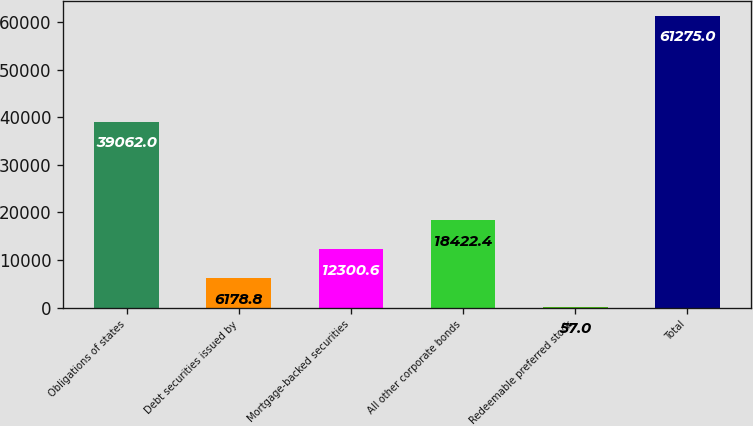<chart> <loc_0><loc_0><loc_500><loc_500><bar_chart><fcel>Obligations of states<fcel>Debt securities issued by<fcel>Mortgage-backed securities<fcel>All other corporate bonds<fcel>Redeemable preferred stock<fcel>Total<nl><fcel>39062<fcel>6178.8<fcel>12300.6<fcel>18422.4<fcel>57<fcel>61275<nl></chart> 